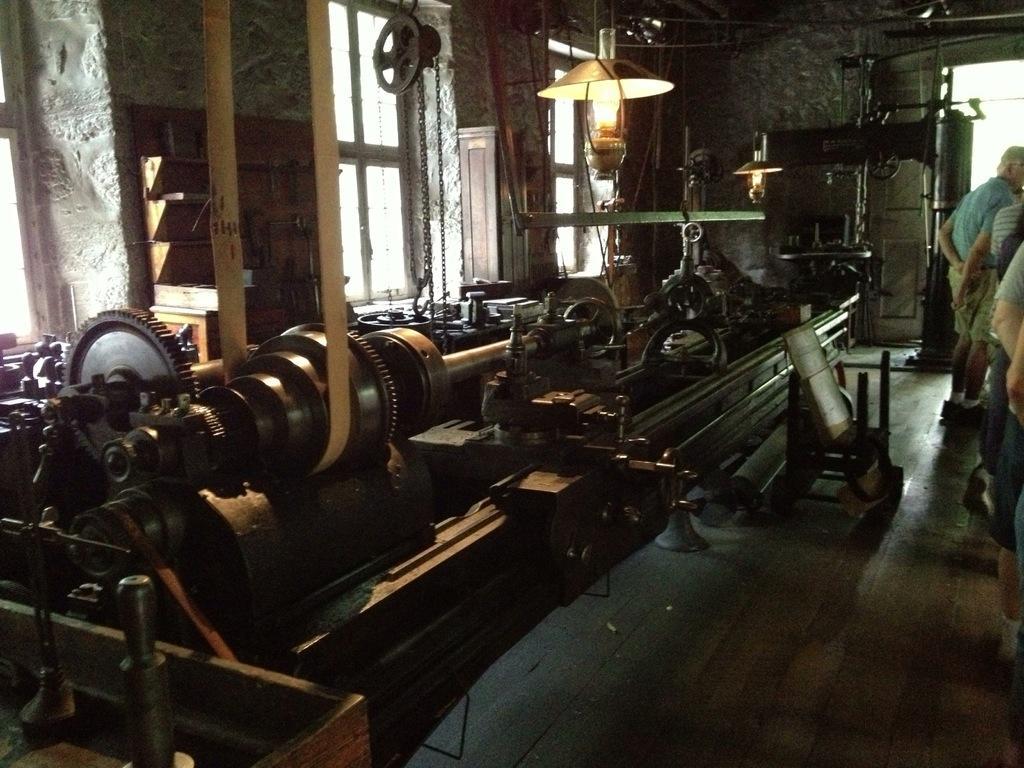In one or two sentences, can you explain what this image depicts? In this image I can see inside view of a room, in the room I can see machines and I can see a lamp attached to the roof and I can see there are few persons standing on the floor on the right side and on the left side I can see windows. 